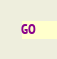<code> <loc_0><loc_0><loc_500><loc_500><_SQL_>GO
</code> 